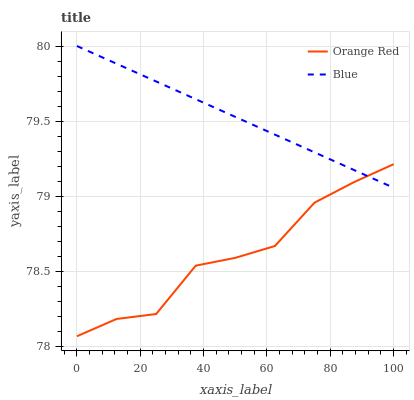Does Orange Red have the maximum area under the curve?
Answer yes or no. No. Is Orange Red the smoothest?
Answer yes or no. No. Does Orange Red have the highest value?
Answer yes or no. No. 